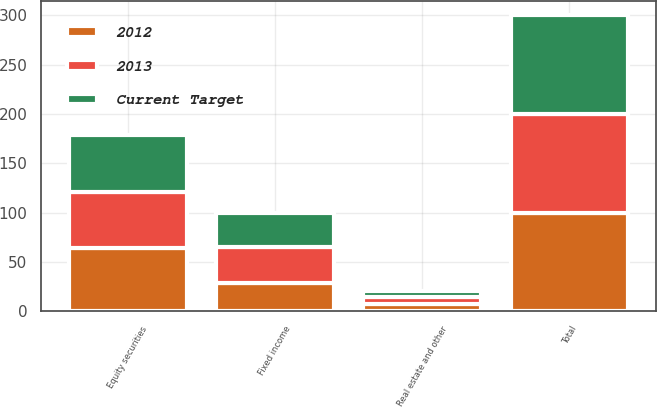Convert chart. <chart><loc_0><loc_0><loc_500><loc_500><stacked_bar_chart><ecel><fcel>Equity securities<fcel>Fixed income<fcel>Real estate and other<fcel>Total<nl><fcel>2012<fcel>64<fcel>29<fcel>7<fcel>100<nl><fcel>2013<fcel>57<fcel>36<fcel>7<fcel>100<nl><fcel>Current Target<fcel>58<fcel>35<fcel>7<fcel>100<nl></chart> 